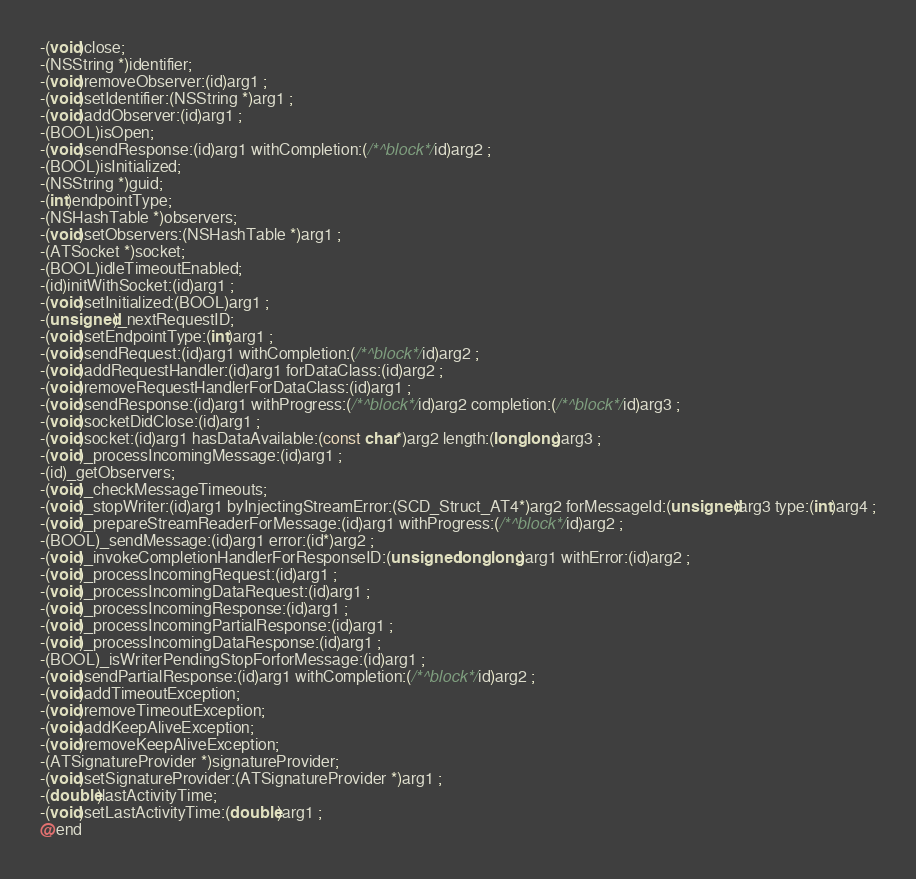<code> <loc_0><loc_0><loc_500><loc_500><_C_>-(void)close;
-(NSString *)identifier;
-(void)removeObserver:(id)arg1 ;
-(void)setIdentifier:(NSString *)arg1 ;
-(void)addObserver:(id)arg1 ;
-(BOOL)isOpen;
-(void)sendResponse:(id)arg1 withCompletion:(/*^block*/id)arg2 ;
-(BOOL)isInitialized;
-(NSString *)guid;
-(int)endpointType;
-(NSHashTable *)observers;
-(void)setObservers:(NSHashTable *)arg1 ;
-(ATSocket *)socket;
-(BOOL)idleTimeoutEnabled;
-(id)initWithSocket:(id)arg1 ;
-(void)setInitialized:(BOOL)arg1 ;
-(unsigned)_nextRequestID;
-(void)setEndpointType:(int)arg1 ;
-(void)sendRequest:(id)arg1 withCompletion:(/*^block*/id)arg2 ;
-(void)addRequestHandler:(id)arg1 forDataClass:(id)arg2 ;
-(void)removeRequestHandlerForDataClass:(id)arg1 ;
-(void)sendResponse:(id)arg1 withProgress:(/*^block*/id)arg2 completion:(/*^block*/id)arg3 ;
-(void)socketDidClose:(id)arg1 ;
-(void)socket:(id)arg1 hasDataAvailable:(const char*)arg2 length:(long long)arg3 ;
-(void)_processIncomingMessage:(id)arg1 ;
-(id)_getObservers;
-(void)_checkMessageTimeouts;
-(void)_stopWriter:(id)arg1 byInjectingStreamError:(SCD_Struct_AT4*)arg2 forMessageId:(unsigned)arg3 type:(int)arg4 ;
-(void)_prepareStreamReaderForMessage:(id)arg1 withProgress:(/*^block*/id)arg2 ;
-(BOOL)_sendMessage:(id)arg1 error:(id*)arg2 ;
-(void)_invokeCompletionHandlerForResponseID:(unsigned long long)arg1 withError:(id)arg2 ;
-(void)_processIncomingRequest:(id)arg1 ;
-(void)_processIncomingDataRequest:(id)arg1 ;
-(void)_processIncomingResponse:(id)arg1 ;
-(void)_processIncomingPartialResponse:(id)arg1 ;
-(void)_processIncomingDataResponse:(id)arg1 ;
-(BOOL)_isWriterPendingStopForforMessage:(id)arg1 ;
-(void)sendPartialResponse:(id)arg1 withCompletion:(/*^block*/id)arg2 ;
-(void)addTimeoutException;
-(void)removeTimeoutException;
-(void)addKeepAliveException;
-(void)removeKeepAliveException;
-(ATSignatureProvider *)signatureProvider;
-(void)setSignatureProvider:(ATSignatureProvider *)arg1 ;
-(double)lastActivityTime;
-(void)setLastActivityTime:(double)arg1 ;
@end

</code> 